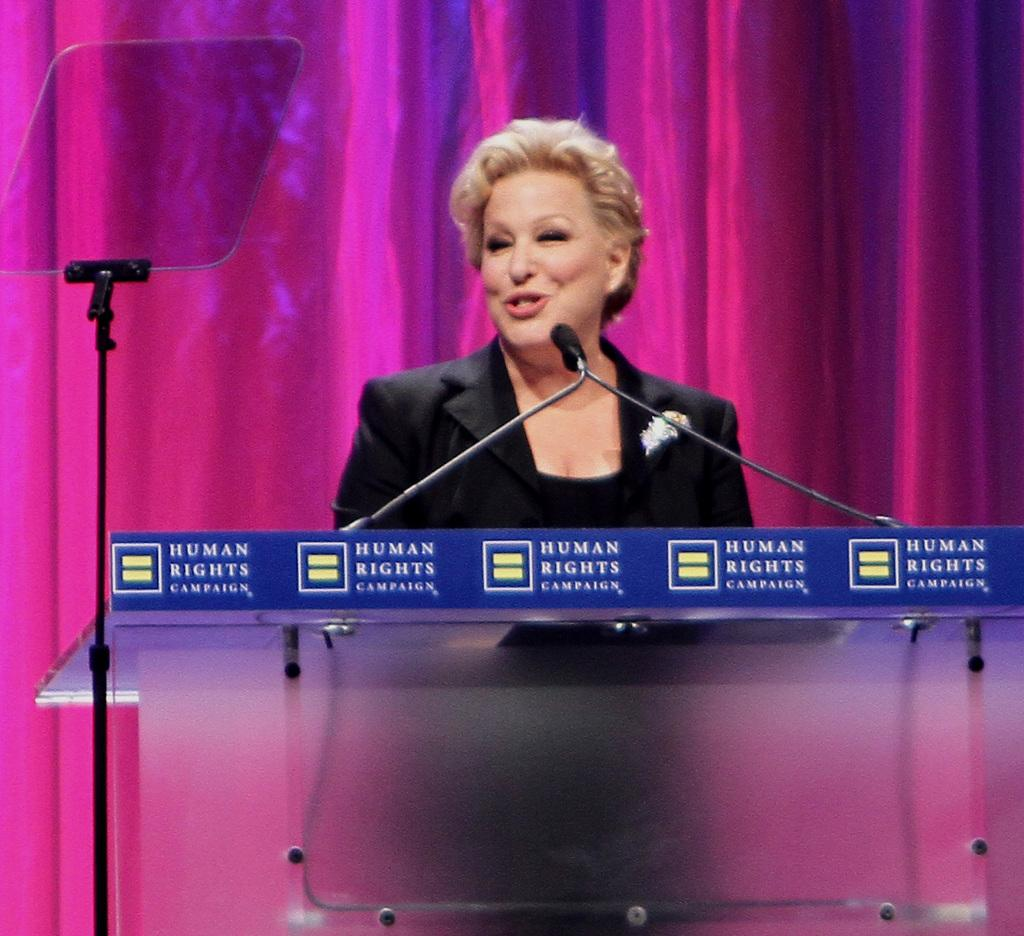What is the main subject of the image? There is a person in the image. What can be observed about the person's attire? The person is wearing clothes. What is the person's position in relation to the podium? The person is standing in front of a podium. What can be seen on the left side of the image? There is an object on the left side of the image. What type of cheese is being used to lead the person in the image? There is no cheese or leading activity present in the image; it features a person standing in front of a podium. 